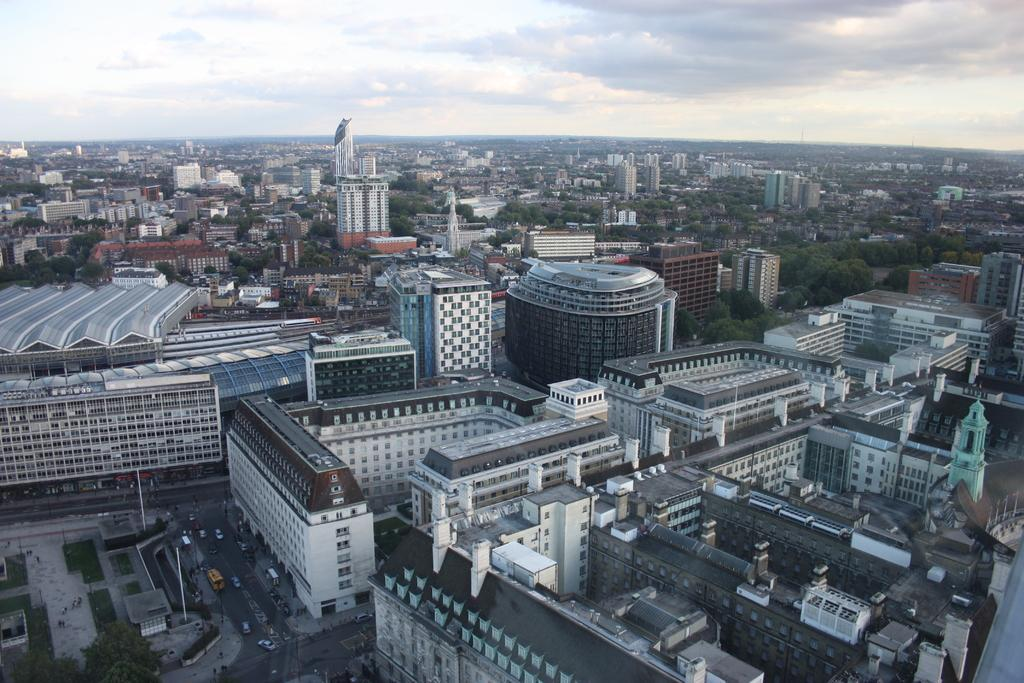What type of location is depicted in the image? The image is of a city. What can be seen on the ground in the image? There are roads in the image. What is moving along the roads in the image? There are vehicles in the image. What structures are present in the image? There are buildings in the image. What type of vegetation can be seen in the image? There are trees in the image. What is visible in the background of the image? The sky is visible in the background of the image. What type of box is being used to store the city's history in the image? There is no box present in the image, nor is there any reference to the city's history. 